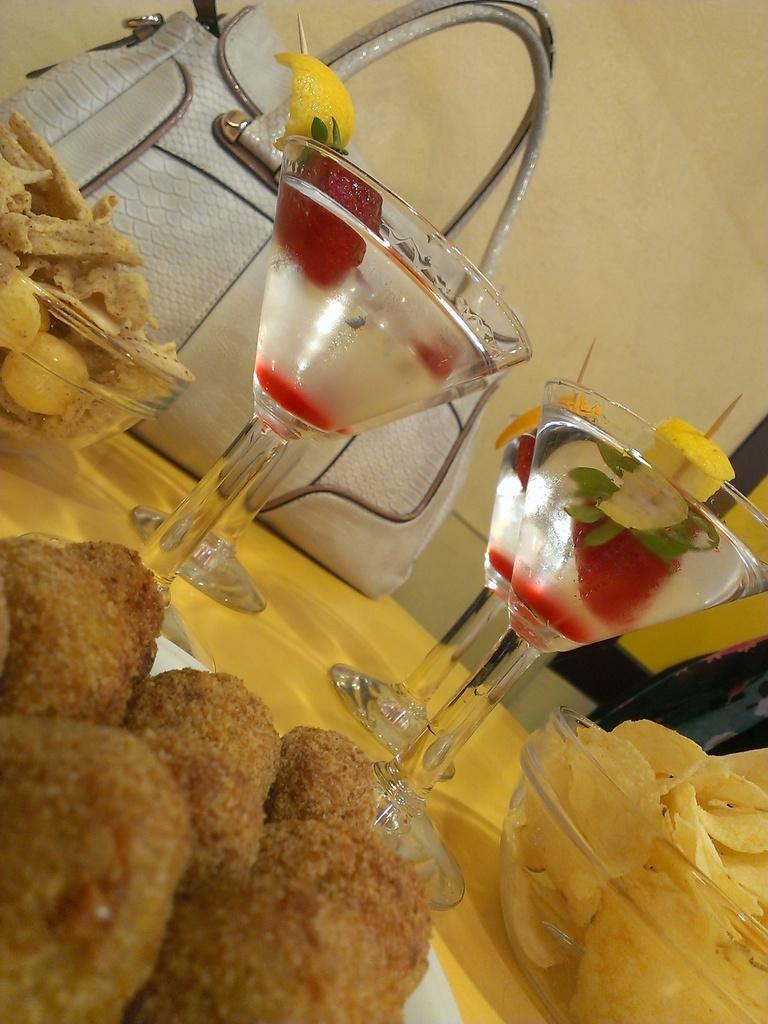Could you give a brief overview of what you see in this image? In this image on a table there are different types of food on plate and bowls. In the glasses there is drink. Here there is a white bag. In the background there is wall. 